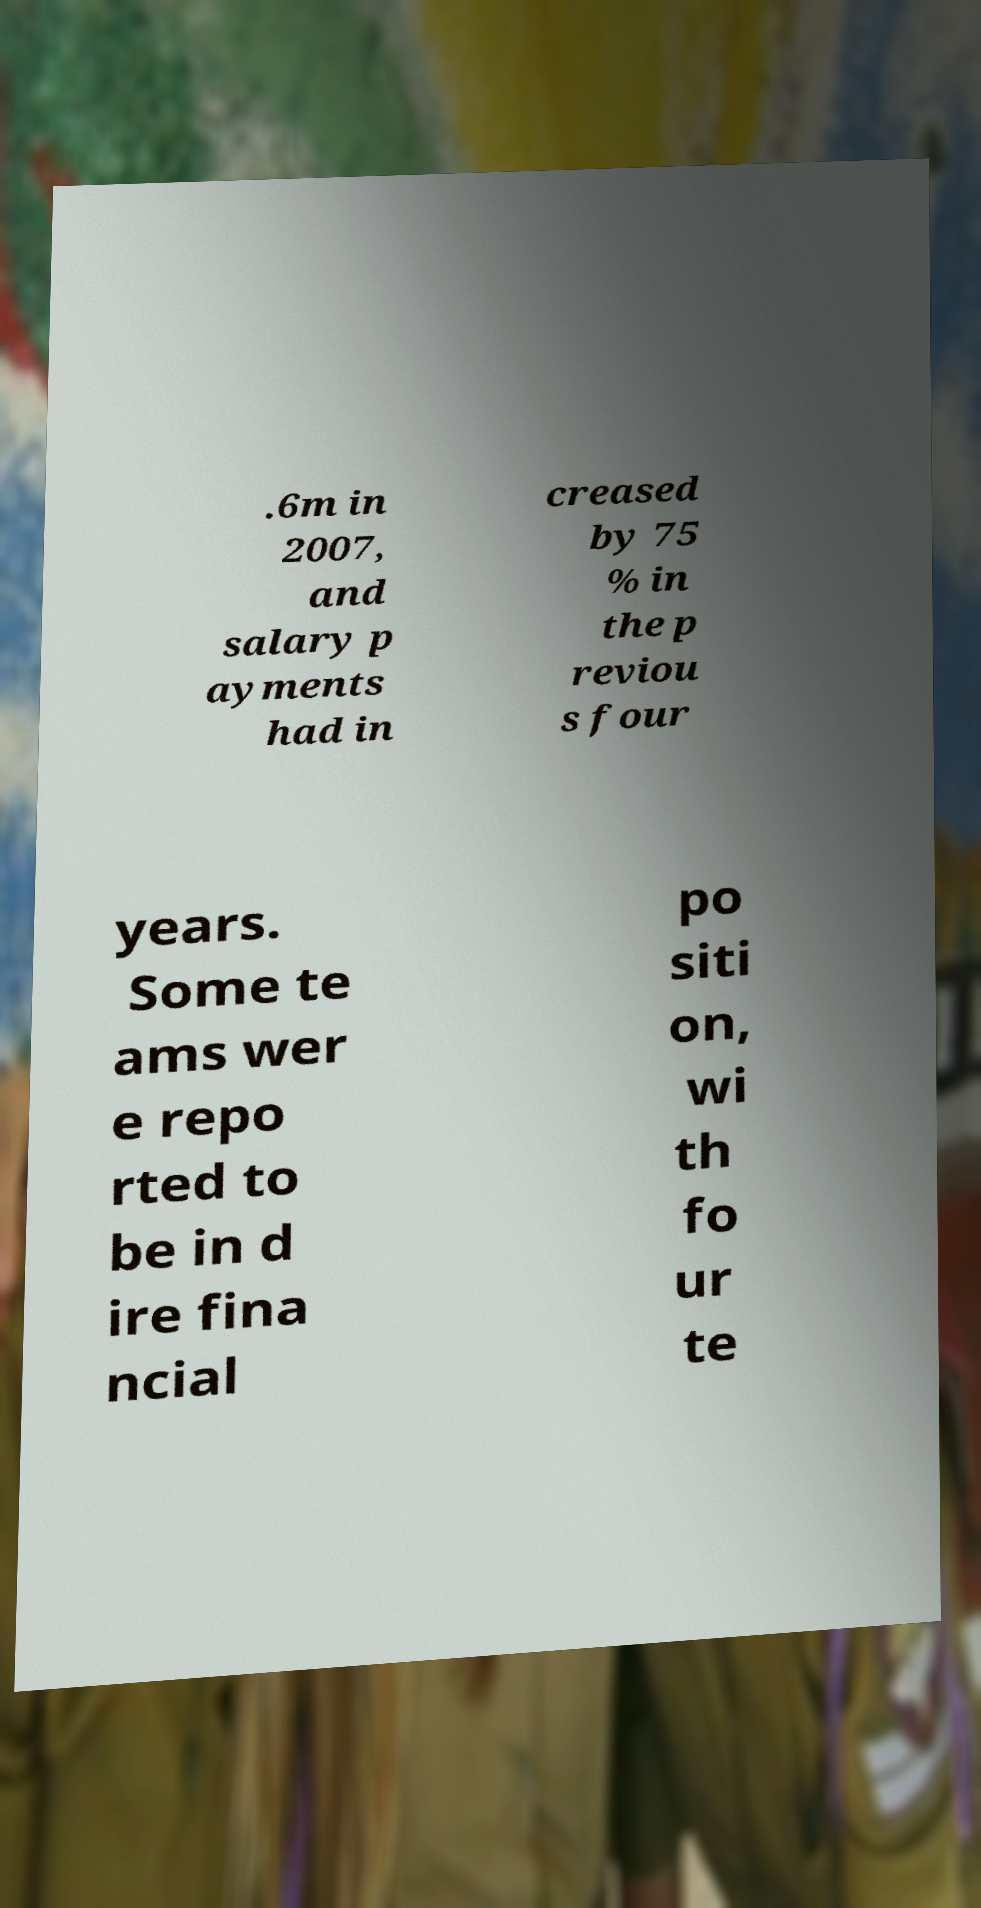I need the written content from this picture converted into text. Can you do that? .6m in 2007, and salary p ayments had in creased by 75 % in the p reviou s four years. Some te ams wer e repo rted to be in d ire fina ncial po siti on, wi th fo ur te 